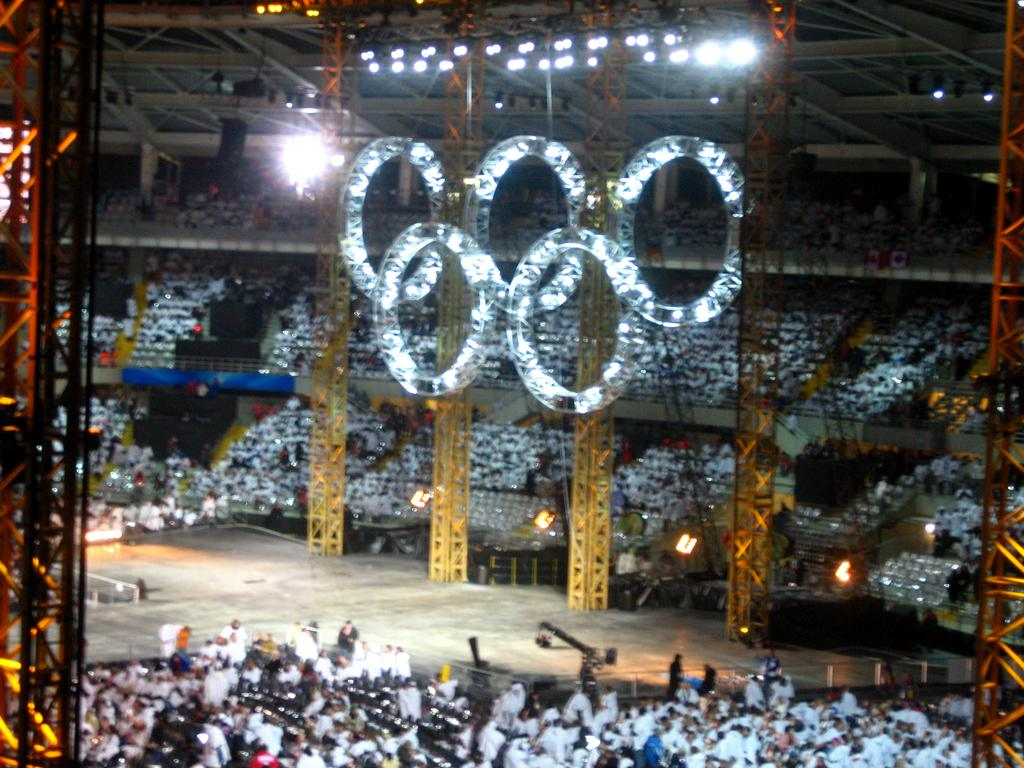What type of building is shown in the image? There is an auditorium in the image. What are the people in the auditorium doing? People are sitting on chairs in the auditorium. What can be seen in the auditorium besides the chairs? There are lights in the auditorium. What type of truck is parked outside the auditorium in the image? There is no truck visible in the image; it only shows the interior of the auditorium. Can you provide a suggestion for improving the lighting in the auditorium based on the image? The image does not provide enough information to make a suggestion for improving the lighting in the auditorium. 